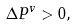Convert formula to latex. <formula><loc_0><loc_0><loc_500><loc_500>\Delta P ^ { v } > 0 ,</formula> 